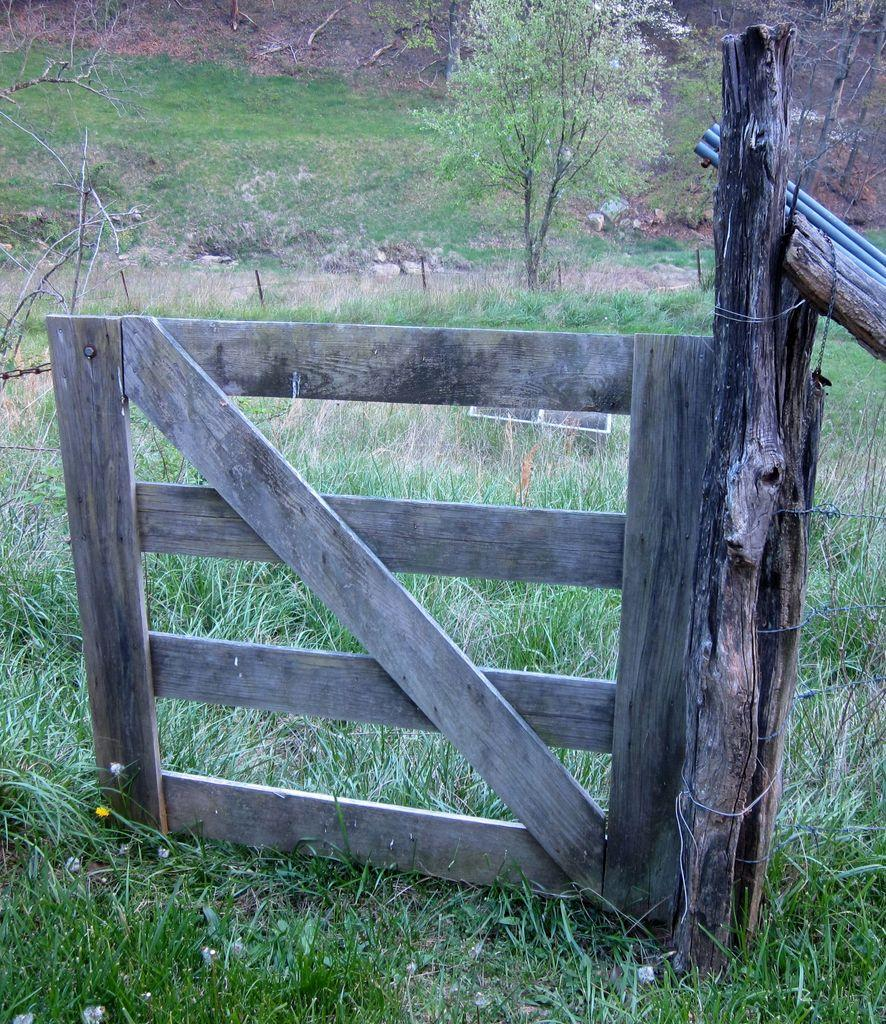What type of door is visible in the image? There is a wooden door in the image. What can be seen in the background of the image? There is grass and trees in the background of the image. How many cows are grazing in the grass in the image? There are no cows present in the image; it only features a wooden door and grass in the background. 